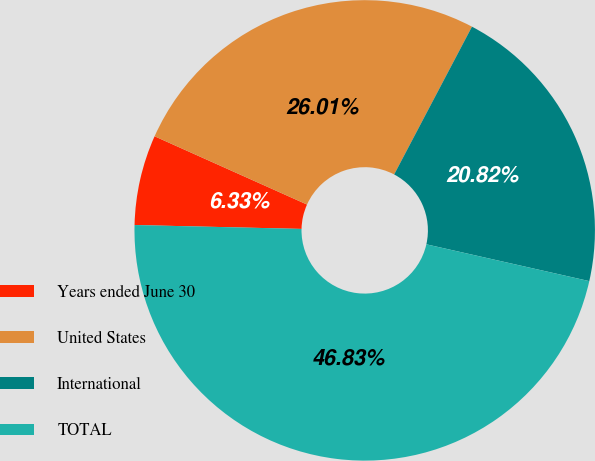<chart> <loc_0><loc_0><loc_500><loc_500><pie_chart><fcel>Years ended June 30<fcel>United States<fcel>International<fcel>TOTAL<nl><fcel>6.33%<fcel>26.01%<fcel>20.82%<fcel>46.83%<nl></chart> 